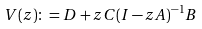Convert formula to latex. <formula><loc_0><loc_0><loc_500><loc_500>V ( z ) \colon = D + z C ( I - z A ) ^ { - 1 } B</formula> 